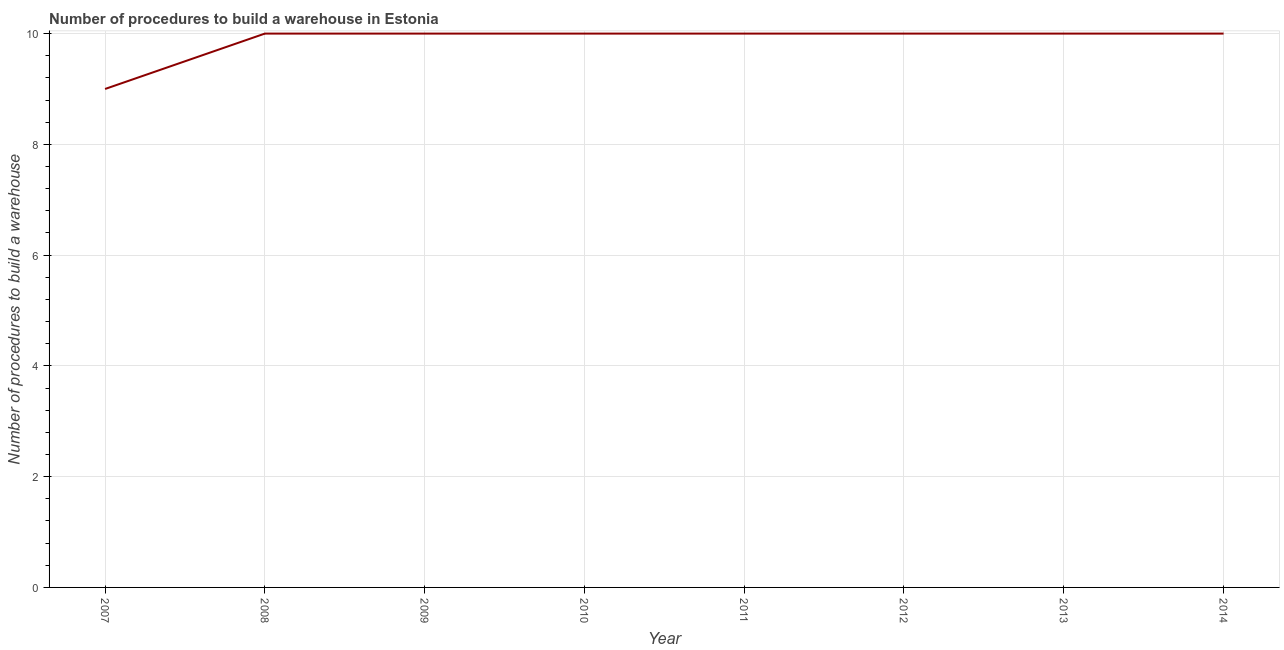What is the number of procedures to build a warehouse in 2011?
Offer a very short reply. 10. Across all years, what is the maximum number of procedures to build a warehouse?
Keep it short and to the point. 10. Across all years, what is the minimum number of procedures to build a warehouse?
Your answer should be compact. 9. In which year was the number of procedures to build a warehouse maximum?
Provide a succinct answer. 2008. What is the sum of the number of procedures to build a warehouse?
Offer a very short reply. 79. What is the difference between the number of procedures to build a warehouse in 2009 and 2014?
Offer a very short reply. 0. What is the average number of procedures to build a warehouse per year?
Give a very brief answer. 9.88. What is the median number of procedures to build a warehouse?
Offer a terse response. 10. In how many years, is the number of procedures to build a warehouse greater than 8.4 ?
Your answer should be compact. 8. What is the ratio of the number of procedures to build a warehouse in 2008 to that in 2011?
Give a very brief answer. 1. Is the difference between the number of procedures to build a warehouse in 2011 and 2013 greater than the difference between any two years?
Your answer should be compact. No. Is the sum of the number of procedures to build a warehouse in 2012 and 2014 greater than the maximum number of procedures to build a warehouse across all years?
Your response must be concise. Yes. What is the difference between the highest and the lowest number of procedures to build a warehouse?
Your answer should be very brief. 1. In how many years, is the number of procedures to build a warehouse greater than the average number of procedures to build a warehouse taken over all years?
Make the answer very short. 7. Does the number of procedures to build a warehouse monotonically increase over the years?
Make the answer very short. No. How many years are there in the graph?
Offer a terse response. 8. Does the graph contain grids?
Provide a short and direct response. Yes. What is the title of the graph?
Your answer should be very brief. Number of procedures to build a warehouse in Estonia. What is the label or title of the Y-axis?
Offer a terse response. Number of procedures to build a warehouse. What is the Number of procedures to build a warehouse in 2007?
Your answer should be compact. 9. What is the Number of procedures to build a warehouse in 2008?
Your response must be concise. 10. What is the Number of procedures to build a warehouse in 2013?
Offer a very short reply. 10. What is the difference between the Number of procedures to build a warehouse in 2007 and 2009?
Provide a short and direct response. -1. What is the difference between the Number of procedures to build a warehouse in 2007 and 2011?
Keep it short and to the point. -1. What is the difference between the Number of procedures to build a warehouse in 2007 and 2012?
Your response must be concise. -1. What is the difference between the Number of procedures to build a warehouse in 2007 and 2013?
Your response must be concise. -1. What is the difference between the Number of procedures to build a warehouse in 2008 and 2009?
Provide a short and direct response. 0. What is the difference between the Number of procedures to build a warehouse in 2008 and 2012?
Offer a terse response. 0. What is the difference between the Number of procedures to build a warehouse in 2008 and 2013?
Make the answer very short. 0. What is the difference between the Number of procedures to build a warehouse in 2009 and 2010?
Provide a short and direct response. 0. What is the difference between the Number of procedures to build a warehouse in 2009 and 2014?
Give a very brief answer. 0. What is the difference between the Number of procedures to build a warehouse in 2010 and 2011?
Offer a terse response. 0. What is the difference between the Number of procedures to build a warehouse in 2010 and 2012?
Your answer should be compact. 0. What is the difference between the Number of procedures to build a warehouse in 2010 and 2013?
Your answer should be compact. 0. What is the difference between the Number of procedures to build a warehouse in 2010 and 2014?
Your answer should be compact. 0. What is the difference between the Number of procedures to build a warehouse in 2011 and 2012?
Offer a terse response. 0. What is the difference between the Number of procedures to build a warehouse in 2011 and 2013?
Ensure brevity in your answer.  0. What is the difference between the Number of procedures to build a warehouse in 2012 and 2013?
Make the answer very short. 0. What is the ratio of the Number of procedures to build a warehouse in 2007 to that in 2008?
Keep it short and to the point. 0.9. What is the ratio of the Number of procedures to build a warehouse in 2008 to that in 2010?
Give a very brief answer. 1. What is the ratio of the Number of procedures to build a warehouse in 2008 to that in 2011?
Make the answer very short. 1. What is the ratio of the Number of procedures to build a warehouse in 2008 to that in 2012?
Offer a terse response. 1. What is the ratio of the Number of procedures to build a warehouse in 2008 to that in 2013?
Make the answer very short. 1. What is the ratio of the Number of procedures to build a warehouse in 2008 to that in 2014?
Your response must be concise. 1. What is the ratio of the Number of procedures to build a warehouse in 2009 to that in 2014?
Your answer should be compact. 1. What is the ratio of the Number of procedures to build a warehouse in 2010 to that in 2012?
Keep it short and to the point. 1. What is the ratio of the Number of procedures to build a warehouse in 2010 to that in 2014?
Offer a very short reply. 1. What is the ratio of the Number of procedures to build a warehouse in 2011 to that in 2013?
Your response must be concise. 1. What is the ratio of the Number of procedures to build a warehouse in 2011 to that in 2014?
Make the answer very short. 1. What is the ratio of the Number of procedures to build a warehouse in 2012 to that in 2013?
Give a very brief answer. 1. 